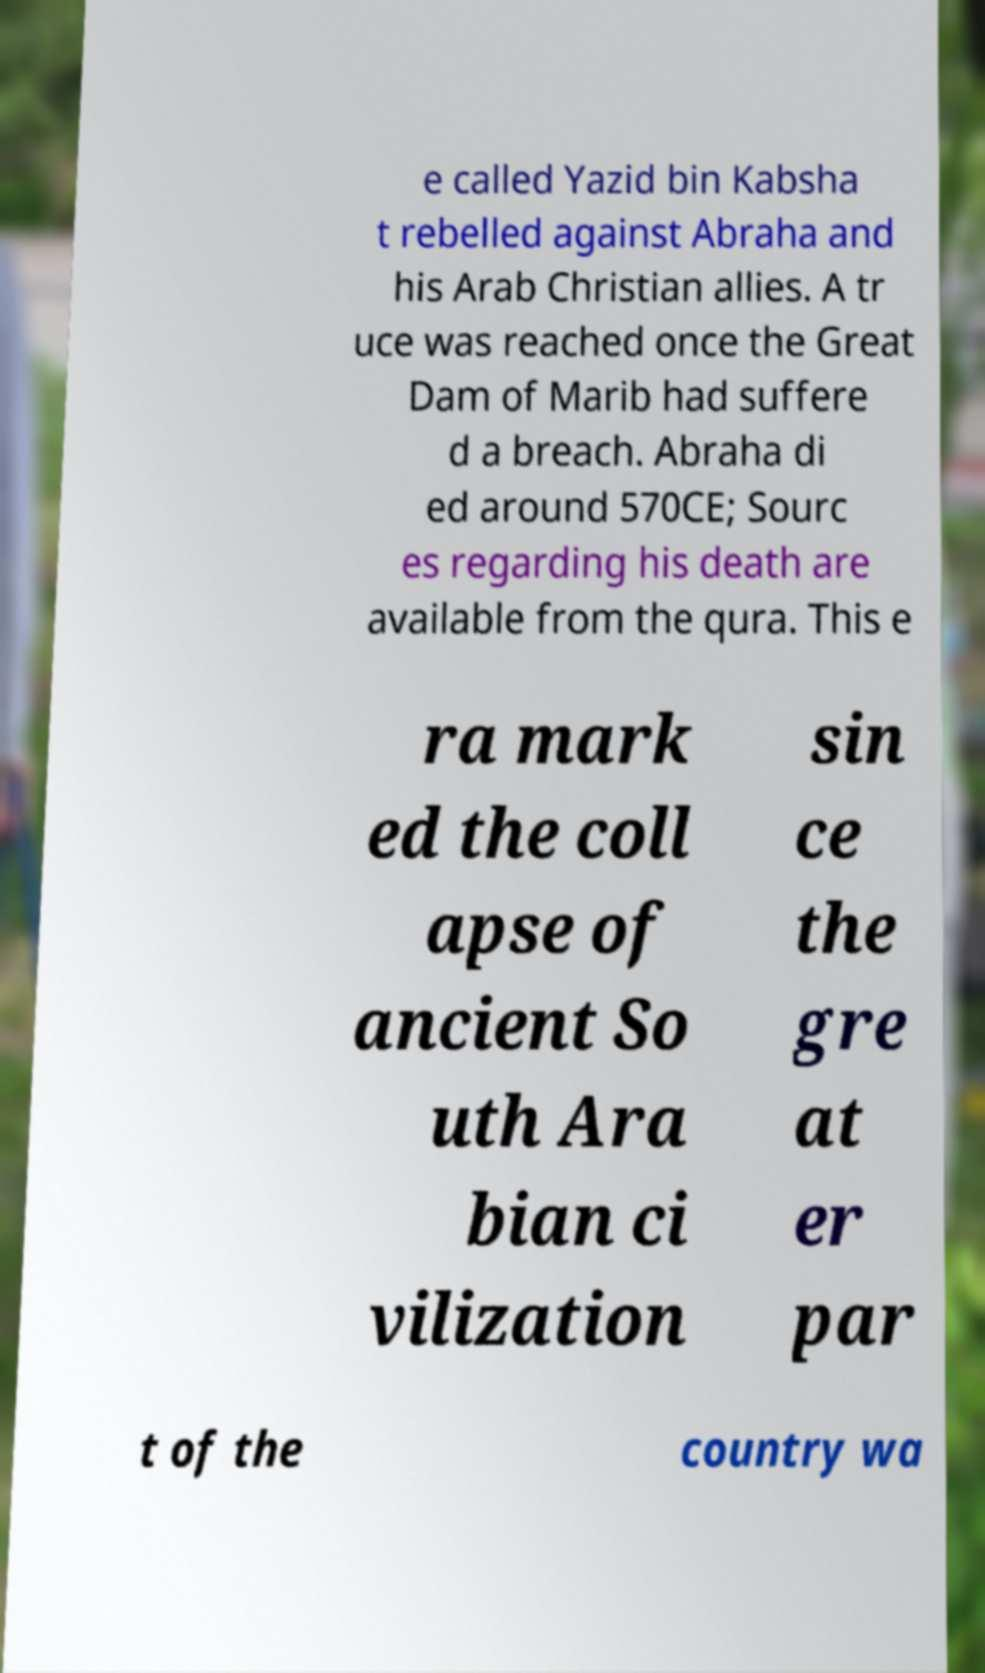For documentation purposes, I need the text within this image transcribed. Could you provide that? e called Yazid bin Kabsha t rebelled against Abraha and his Arab Christian allies. A tr uce was reached once the Great Dam of Marib had suffere d a breach. Abraha di ed around 570CE; Sourc es regarding his death are available from the qura. This e ra mark ed the coll apse of ancient So uth Ara bian ci vilization sin ce the gre at er par t of the country wa 